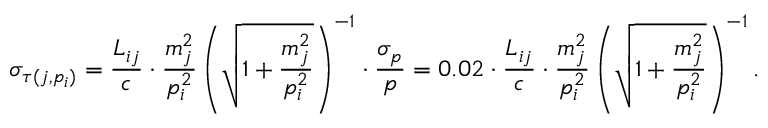Convert formula to latex. <formula><loc_0><loc_0><loc_500><loc_500>\sigma _ { \tau ( j , p _ { i } ) } = \frac { L _ { i j } } { c } \cdot \frac { m _ { j } ^ { 2 } } { p _ { i } ^ { 2 } } \left ( \sqrt { 1 + \frac { m _ { j } ^ { 2 } } { p _ { i } ^ { 2 } } } \right ) ^ { - 1 } \cdot \frac { \sigma _ { p } } { p } = 0 . 0 2 \cdot \frac { L _ { i j } } { c } \cdot \frac { m _ { j } ^ { 2 } } { p _ { i } ^ { 2 } } \left ( \sqrt { 1 + \frac { m _ { j } ^ { 2 } } { p _ { i } ^ { 2 } } } \right ) ^ { - 1 } .</formula> 